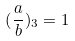Convert formula to latex. <formula><loc_0><loc_0><loc_500><loc_500>( \frac { a } { b } ) _ { 3 } = 1</formula> 